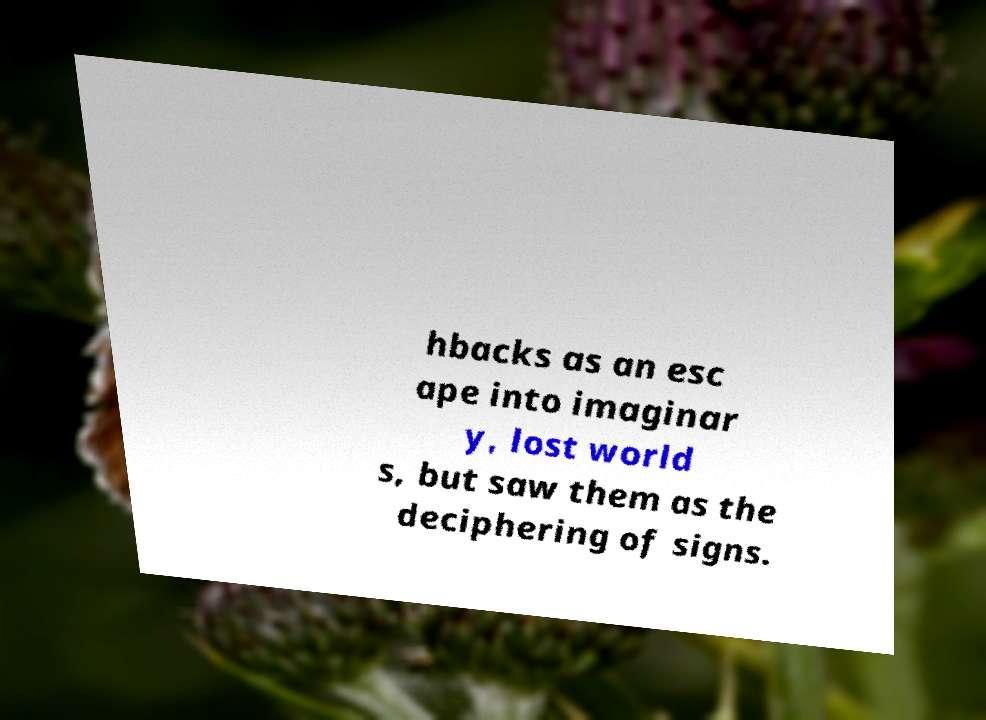I need the written content from this picture converted into text. Can you do that? hbacks as an esc ape into imaginar y, lost world s, but saw them as the deciphering of signs. 